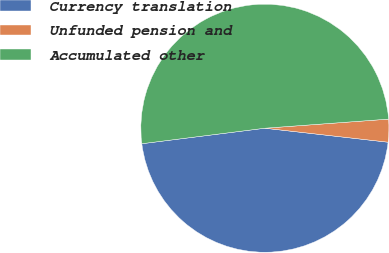<chart> <loc_0><loc_0><loc_500><loc_500><pie_chart><fcel>Currency translation<fcel>Unfunded pension and<fcel>Accumulated other<nl><fcel>46.21%<fcel>2.97%<fcel>50.83%<nl></chart> 